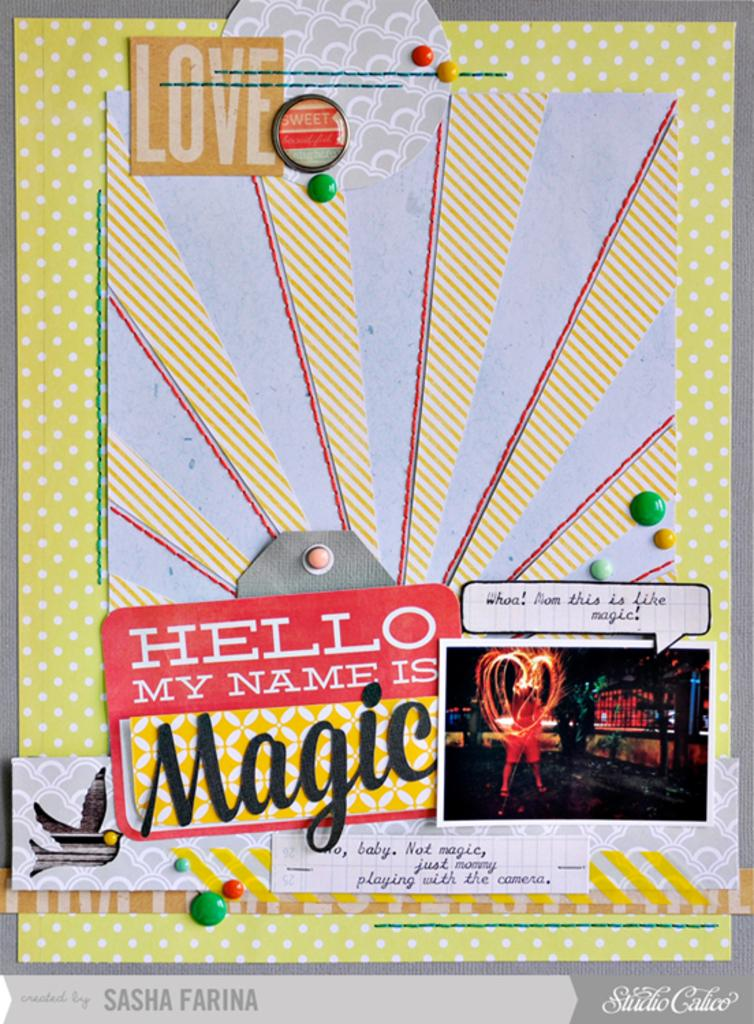<image>
Provide a brief description of the given image. A name tag gives the name magic next to a picture of someone. 